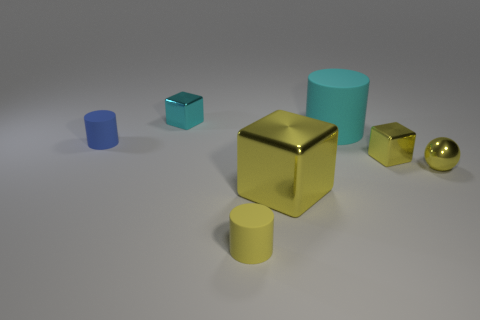Which object in the image reflects the most light, appearing the shiniest? The gold-colored cube in the center of the image appears to have the shiniest surface, reflecting the most light in comparison to the other objects. 